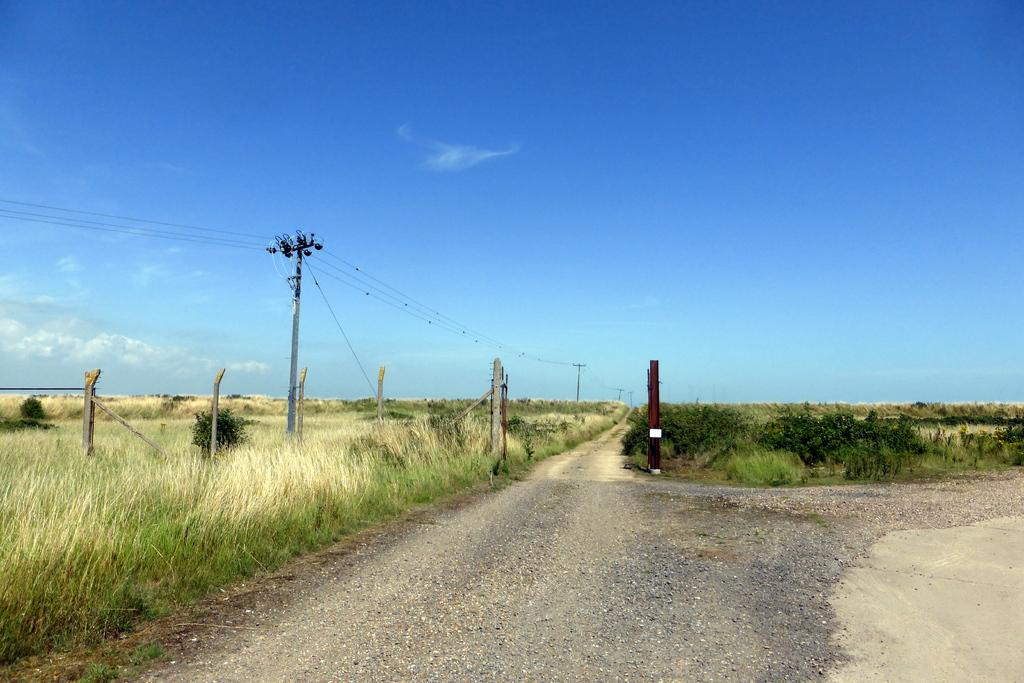What type of surface can be seen in the image? There is a road in the image. What type of vegetation is visible in the image? Crops and grass are visible in the image. What structures are present in the image? Poles and power line cables are present in the image. What is visible at the top of the image? The sky is visible at the top of the image. Can you describe the vegetation in the middle of the image? Grass is visible in the middle of the image. How many owls can be seen perched on the power line cables in the image? There are no owls present in the image; only poles, power line cables, crops, grass, and the sky are visible. What type of snake is slithering across the road in the image? There is no snake visible in the image; it only features a road, crops, grass, poles, power line cables, and the sky. 